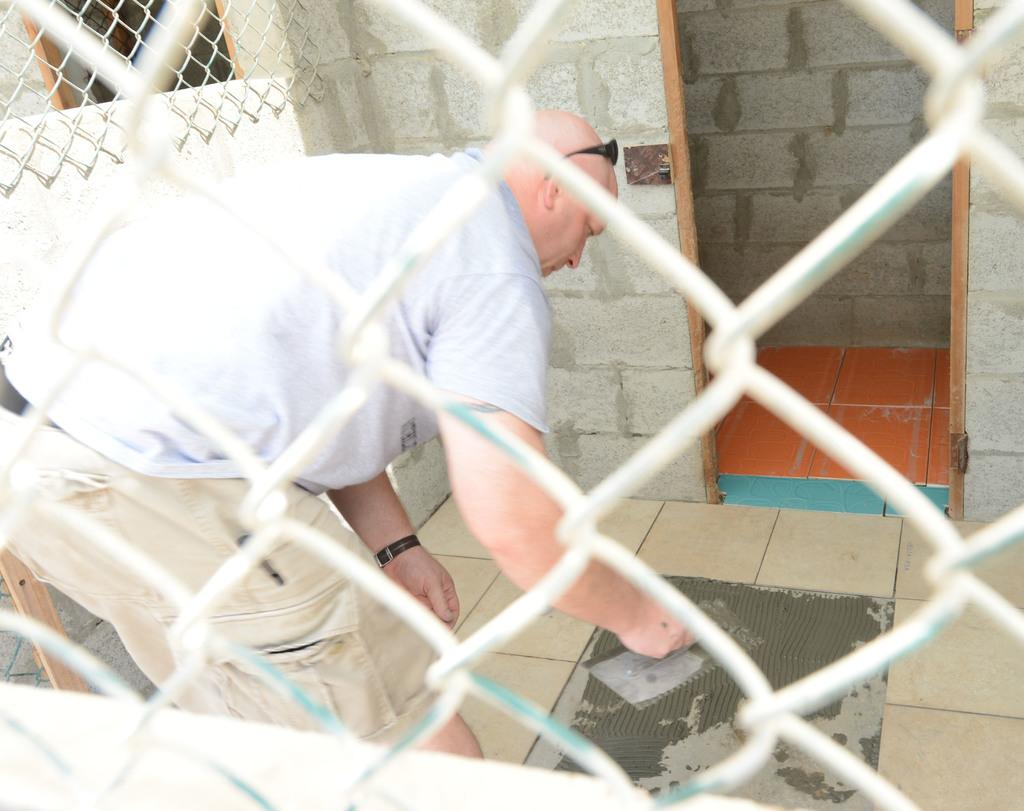What is located in the foreground of the image? There is a net in the foreground of the image. Who is positioned behind the net? There is a man behind the net. What is the man holding in his hand? The man is holding an object in his hand. What is the man's posture in the image? The man is bending. What can be seen in the background of the image? There is a room in the background of the image. How many lamps are present in the image? There is no lamp visible in the image. What type of snakes can be seen slithering on the floor in the image? There are no snakes present in the image. 